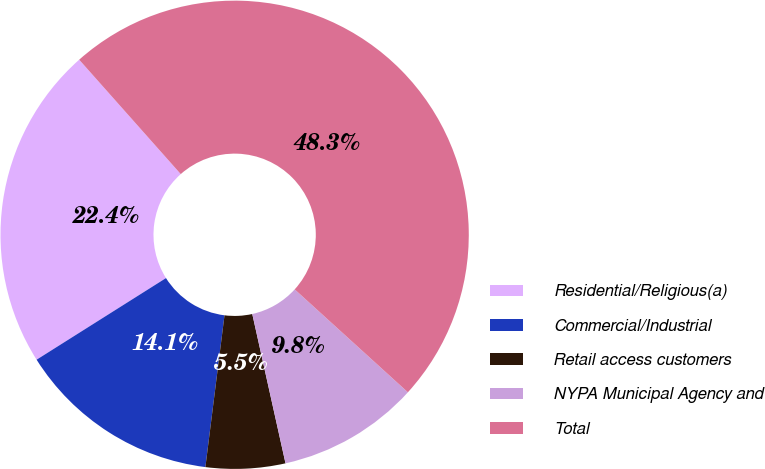Convert chart to OTSL. <chart><loc_0><loc_0><loc_500><loc_500><pie_chart><fcel>Residential/Religious(a)<fcel>Commercial/Industrial<fcel>Retail access customers<fcel>NYPA Municipal Agency and<fcel>Total<nl><fcel>22.4%<fcel>14.05%<fcel>5.48%<fcel>9.77%<fcel>48.3%<nl></chart> 